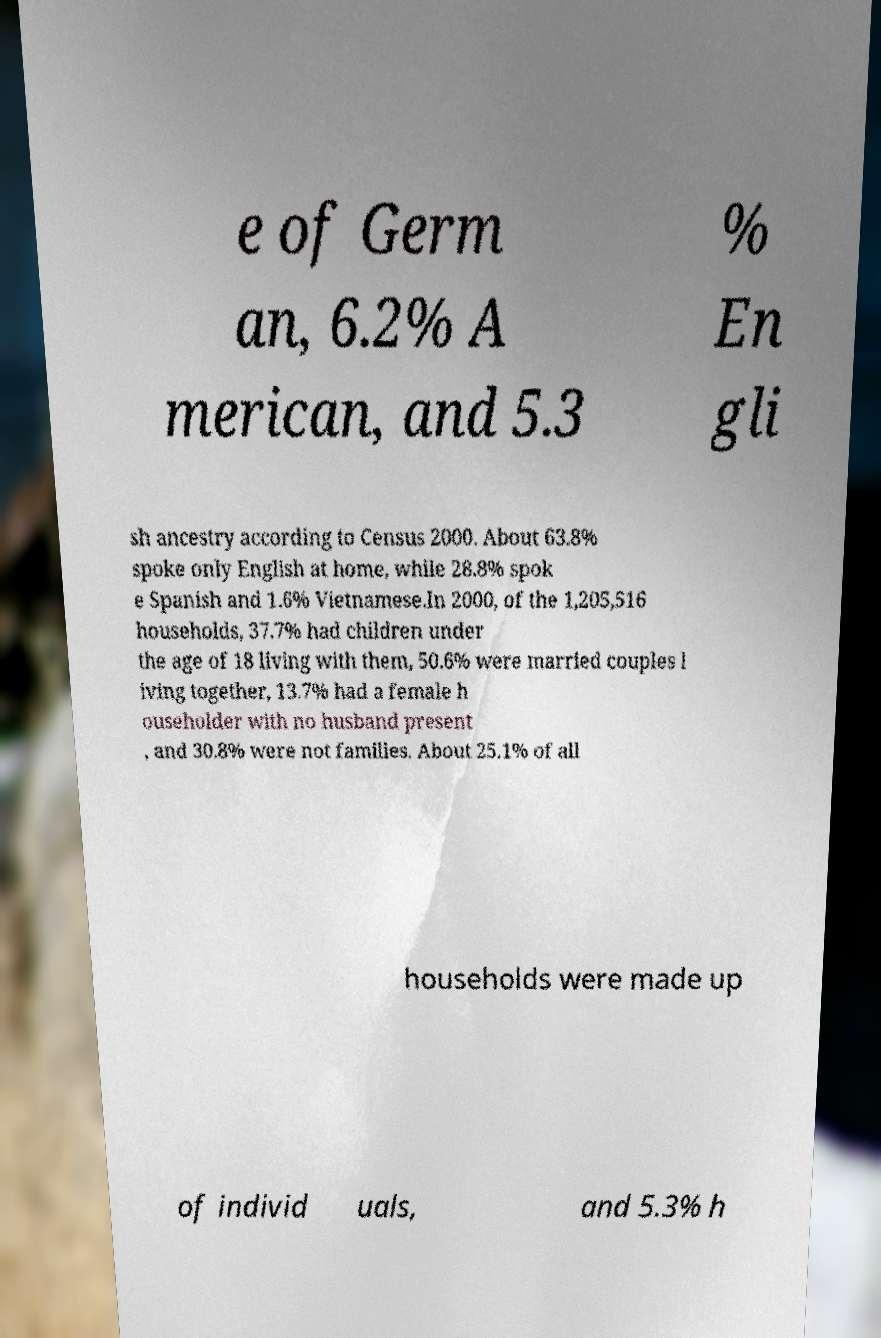Can you accurately transcribe the text from the provided image for me? e of Germ an, 6.2% A merican, and 5.3 % En gli sh ancestry according to Census 2000. About 63.8% spoke only English at home, while 28.8% spok e Spanish and 1.6% Vietnamese.In 2000, of the 1,205,516 households, 37.7% had children under the age of 18 living with them, 50.6% were married couples l iving together, 13.7% had a female h ouseholder with no husband present , and 30.8% were not families. About 25.1% of all households were made up of individ uals, and 5.3% h 